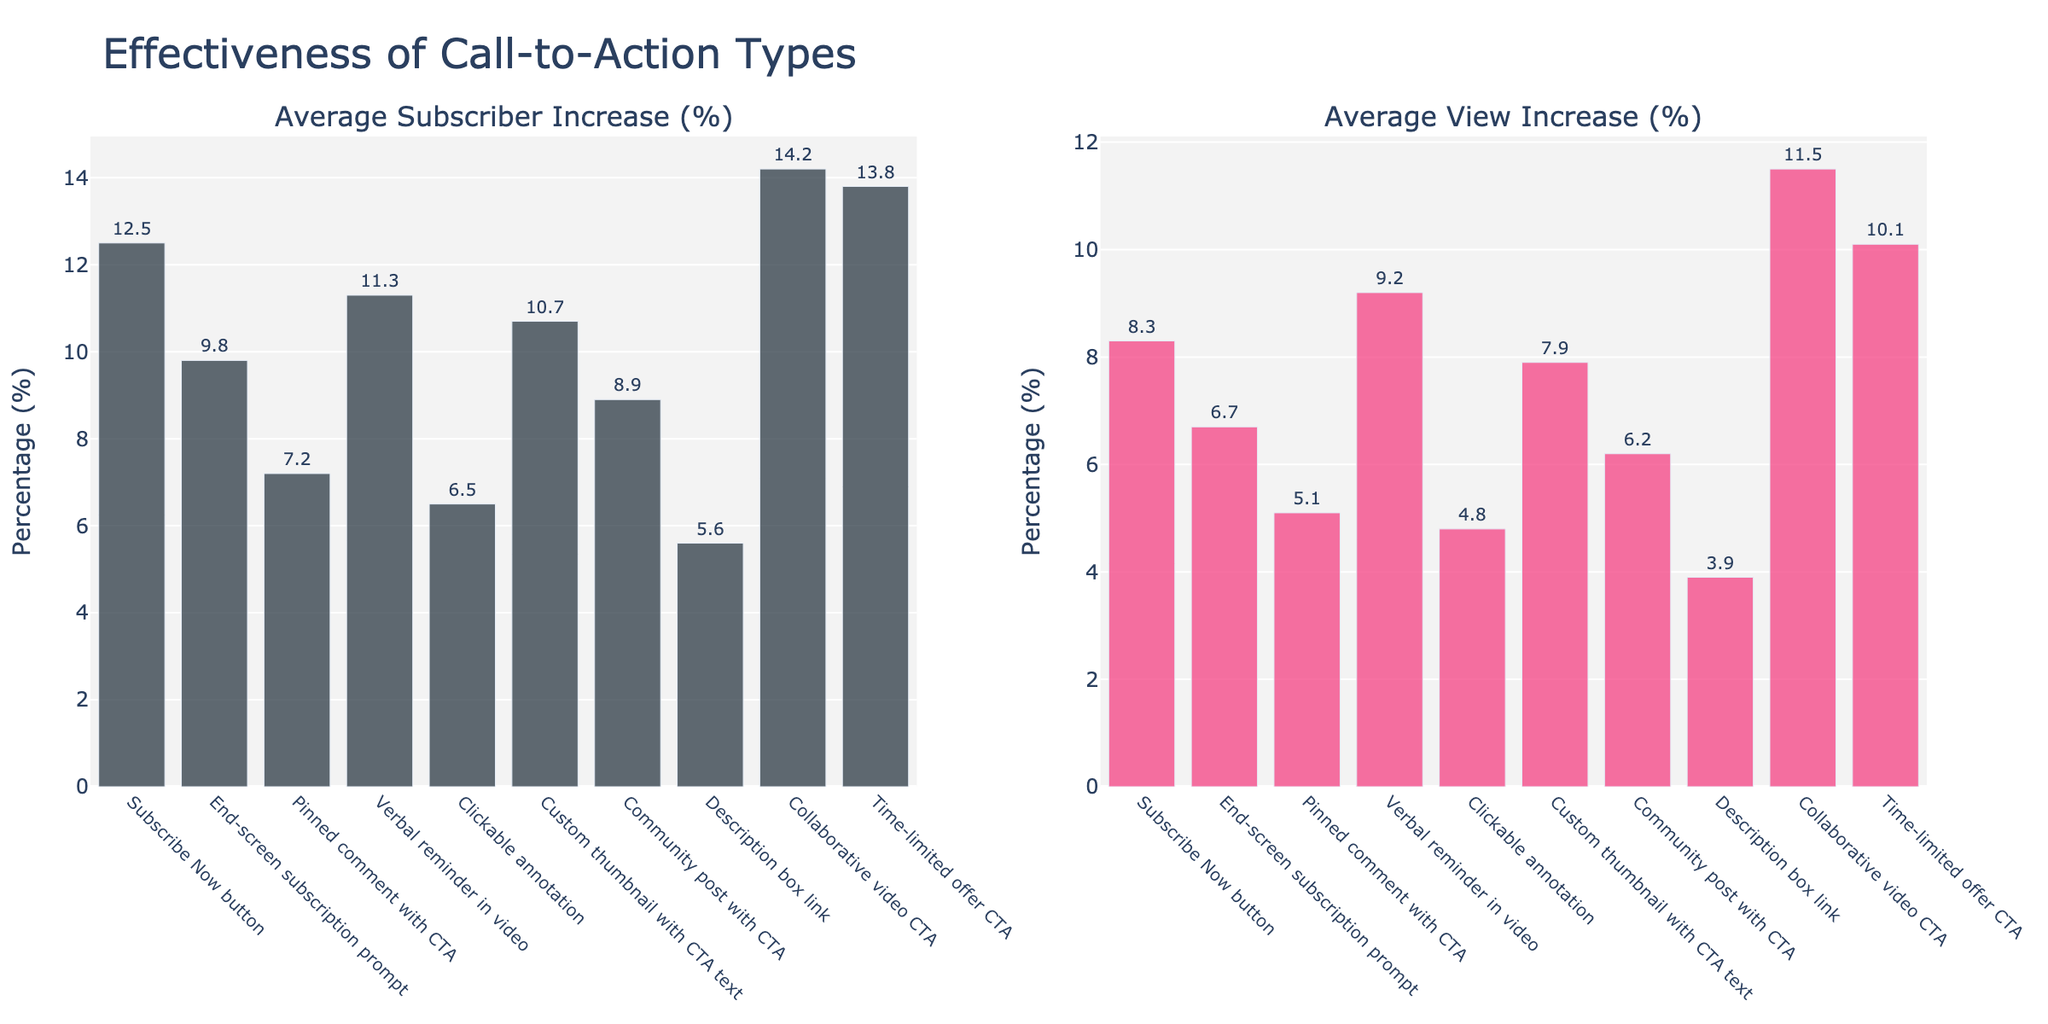What's the most effective call-to-action in increasing subscribers? The bar chart shows that "Collaborative video CTA" has the highest percentage for average subscriber increase.
Answer: Collaborative video CTA Which call-to-action type has a higher average view increase: "Verbal reminder in video" or "End-screen subscription prompt"? By comparing their bar heights and labels, "Verbal reminder in video" (9.2%) is higher than "End screen subscription prompt" (6.7%).
Answer: Verbal reminder in video What is the difference in average subscriber increase between "Subscribe Now" button and "Description box link"? "Subscribe Now" button has an average subscriber increase of 12.5%, and "Description box link" has 5.6%. The difference is 12.5% - 5.6%.
Answer: 6.9% What's the combined average view increase for "Pinned comment with CTA" and "Community post with CTA"? The average view increase for "Pinned comment with CTA" is 5.1%, and for "Community post with CTA" it is 6.2%. Combined is 5.1% + 6.2%.
Answer: 11.3% Which call-to-action type has the lowest effectiveness in increasing views? The chart shows that "Description box link" has the lowest percentage for average view increase at 3.9%.
Answer: Description box link Is the "Custom thumbnail with CTA text" more effective at increasing subscribers or views? The chart shows that "Custom thumbnail with CTA text" has a subscriber increase of 10.7% and a view increase of 7.9%. It is more effective at increasing subscribers.
Answer: Subscribers How much more effective is the "Time-limited offer CTA" compared to "Clickable annotation" in increasing views? "Time-limited offer CTA" has an average view increase of 10.1%, and "Clickable annotation" has 4.8%. Difference = 10.1% - 4.8%.
Answer: 5.3% What's the total average subscriber increase for the four most effective call-to-action types? The four most effective types are "Collaborative video CTA" (14.2%), "Time-limited offer CTA" (13.8%), "Subscribe Now" button (12.5%), and "Verbal reminder in video" (11.3%). Total = 14.2% + 13.8% + 12.5% + 11.3%.
Answer: 51.8% Which call-to-action type besides "Collaborative video CTA" shows an average subscriber increase above 13%? The chart shows "Time-limited offer CTA" has an average subscriber increase of 13.8%.
Answer: Time-limited offer CTA What is the average increase in views for all call-to-action types combined? Sum the view increases for all types: 8.3 + 6.7 + 5.1 + 9.2 + 4.8 + 7.9 + 6.2 + 3.9 + 11.5 + 10.1 = 73.7. Divide by the number of CTA types (10).
Answer: 7.37% 